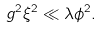Convert formula to latex. <formula><loc_0><loc_0><loc_500><loc_500>g ^ { 2 } \xi ^ { 2 } \ll \lambda \phi ^ { 2 } .</formula> 